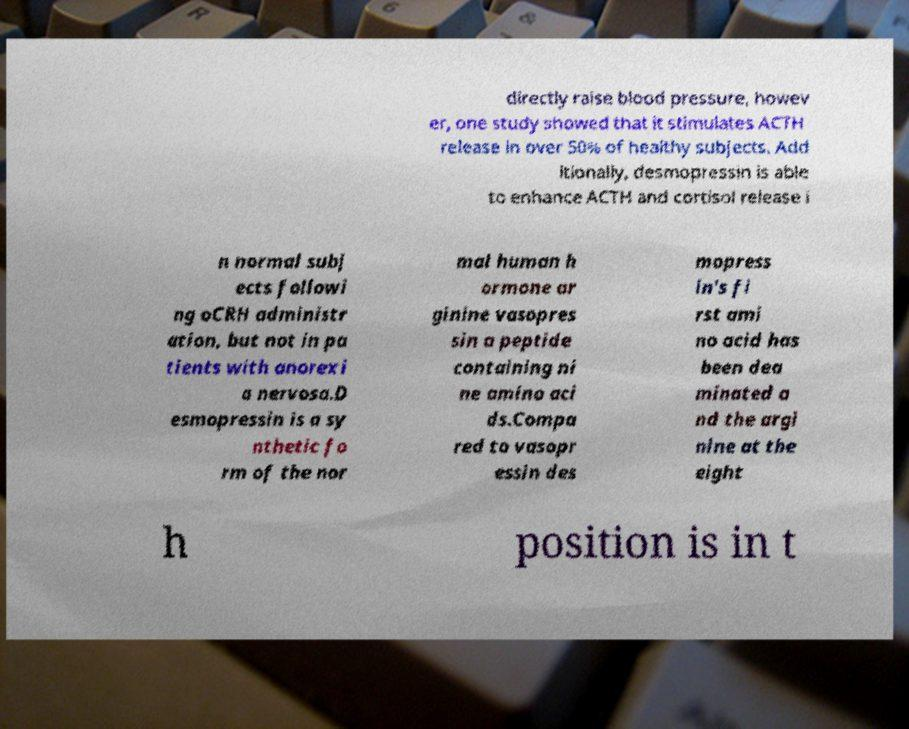For documentation purposes, I need the text within this image transcribed. Could you provide that? directly raise blood pressure, howev er, one study showed that it stimulates ACTH release in over 50% of healthy subjects. Add itionally, desmopressin is able to enhance ACTH and cortisol release i n normal subj ects followi ng oCRH administr ation, but not in pa tients with anorexi a nervosa.D esmopressin is a sy nthetic fo rm of the nor mal human h ormone ar ginine vasopres sin a peptide containing ni ne amino aci ds.Compa red to vasopr essin des mopress in's fi rst ami no acid has been dea minated a nd the argi nine at the eight h position is in t 